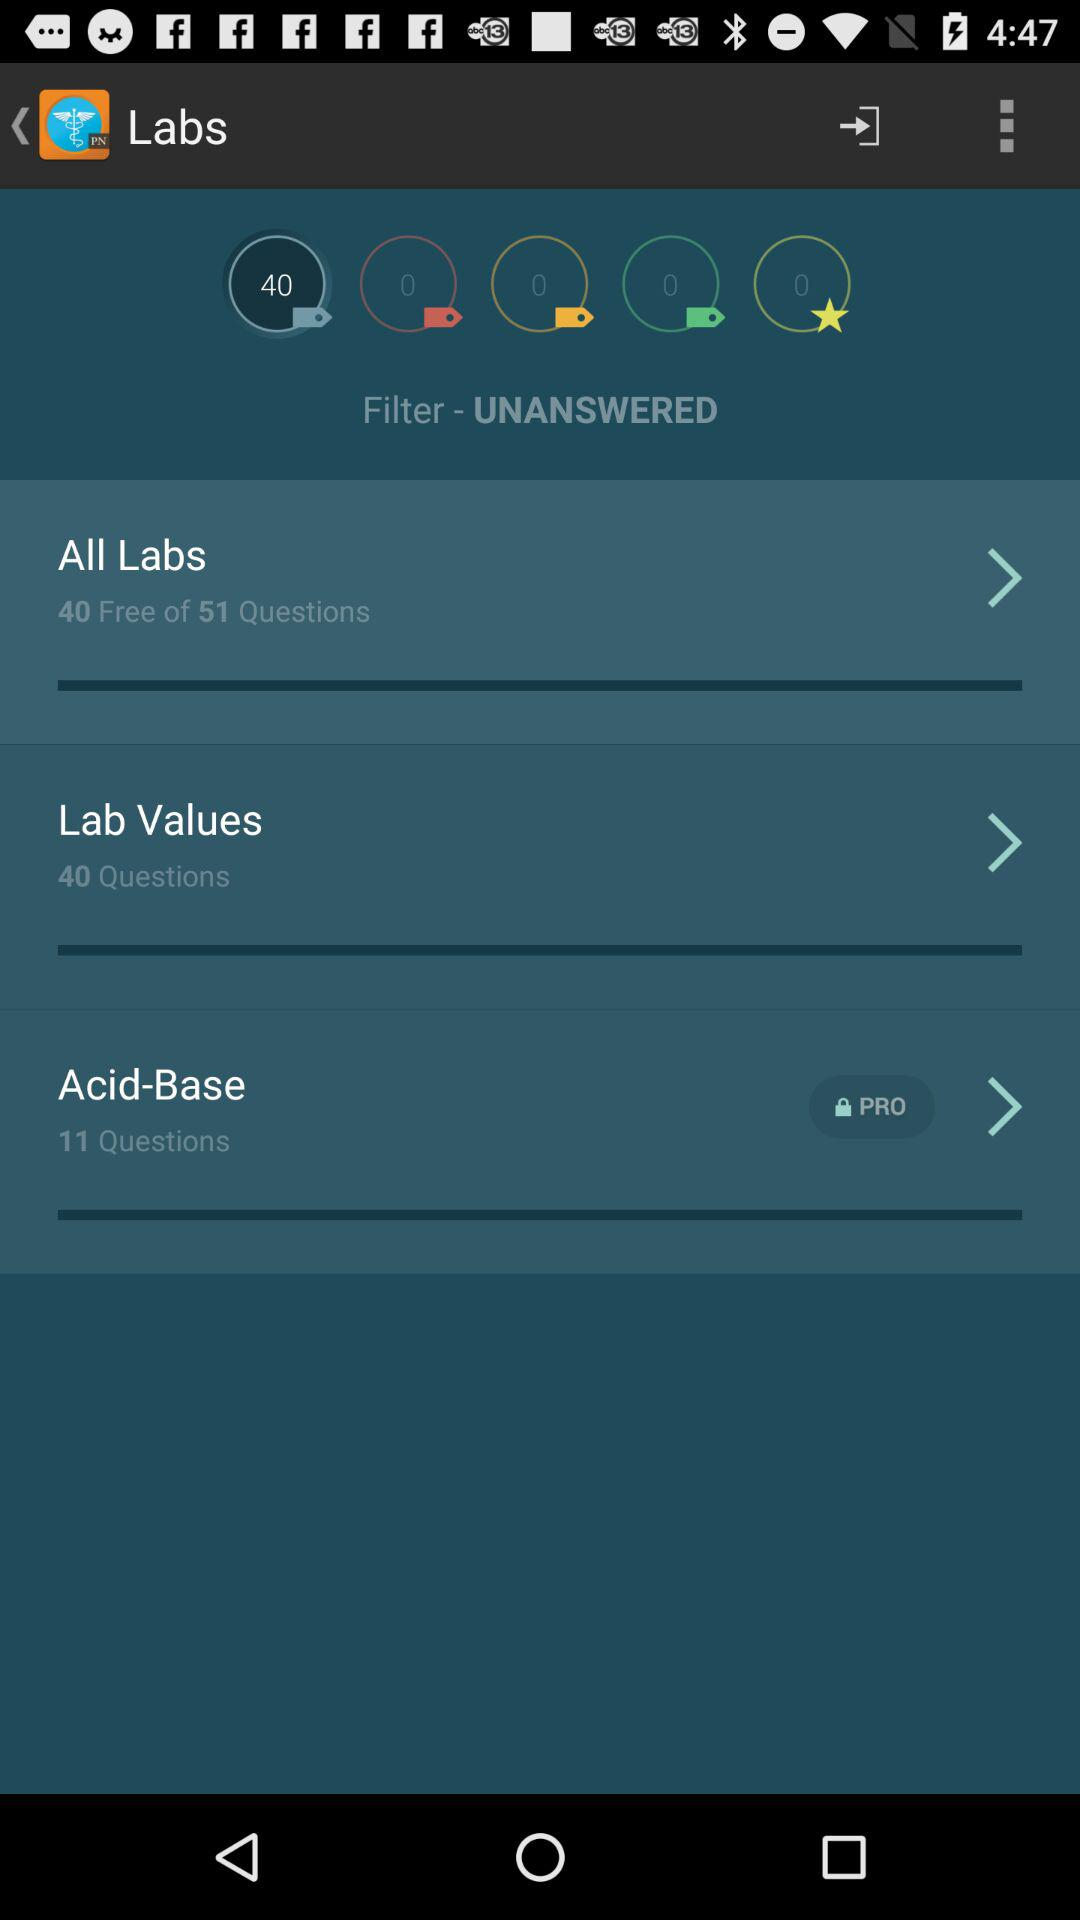What is the total number of questions in "Acid-Base"? The total number of questions in "Acid-Base" is 11. 